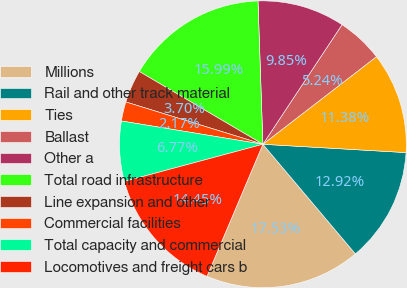Convert chart. <chart><loc_0><loc_0><loc_500><loc_500><pie_chart><fcel>Millions<fcel>Rail and other track material<fcel>Ties<fcel>Ballast<fcel>Other a<fcel>Total road infrastructure<fcel>Line expansion and other<fcel>Commercial facilities<fcel>Total capacity and commercial<fcel>Locomotives and freight cars b<nl><fcel>17.53%<fcel>12.92%<fcel>11.38%<fcel>5.24%<fcel>9.85%<fcel>15.99%<fcel>3.7%<fcel>2.17%<fcel>6.77%<fcel>14.45%<nl></chart> 